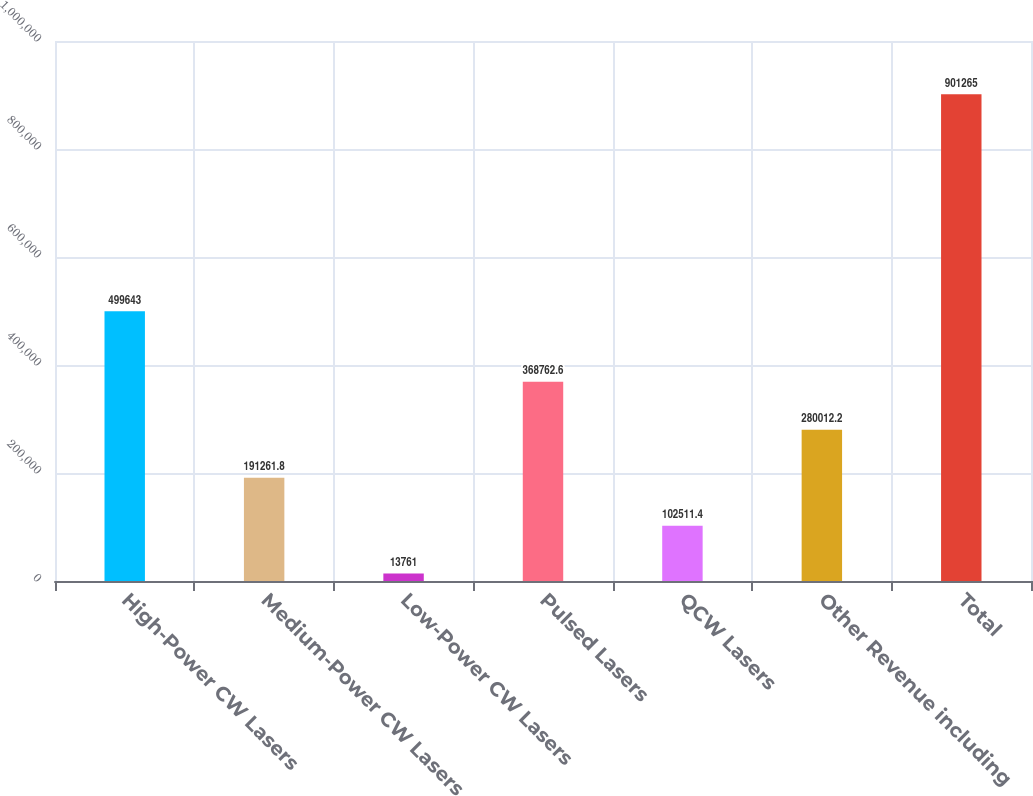Convert chart. <chart><loc_0><loc_0><loc_500><loc_500><bar_chart><fcel>High-Power CW Lasers<fcel>Medium-Power CW Lasers<fcel>Low-Power CW Lasers<fcel>Pulsed Lasers<fcel>QCW Lasers<fcel>Other Revenue including<fcel>Total<nl><fcel>499643<fcel>191262<fcel>13761<fcel>368763<fcel>102511<fcel>280012<fcel>901265<nl></chart> 